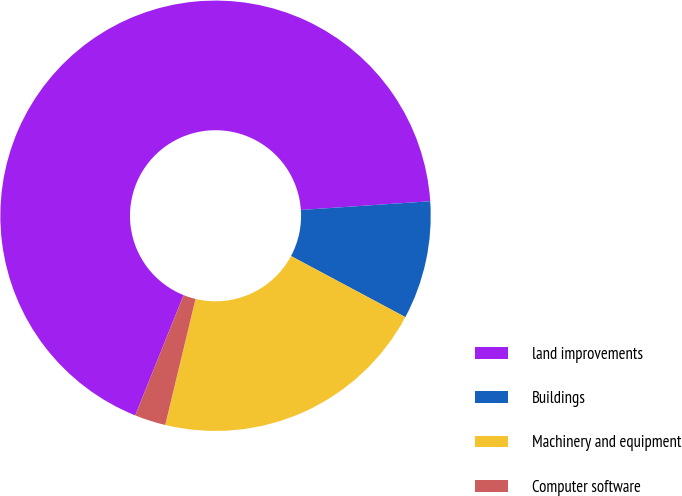Convert chart to OTSL. <chart><loc_0><loc_0><loc_500><loc_500><pie_chart><fcel>land improvements<fcel>Buildings<fcel>Machinery and equipment<fcel>Computer software<nl><fcel>67.84%<fcel>8.88%<fcel>20.95%<fcel>2.33%<nl></chart> 